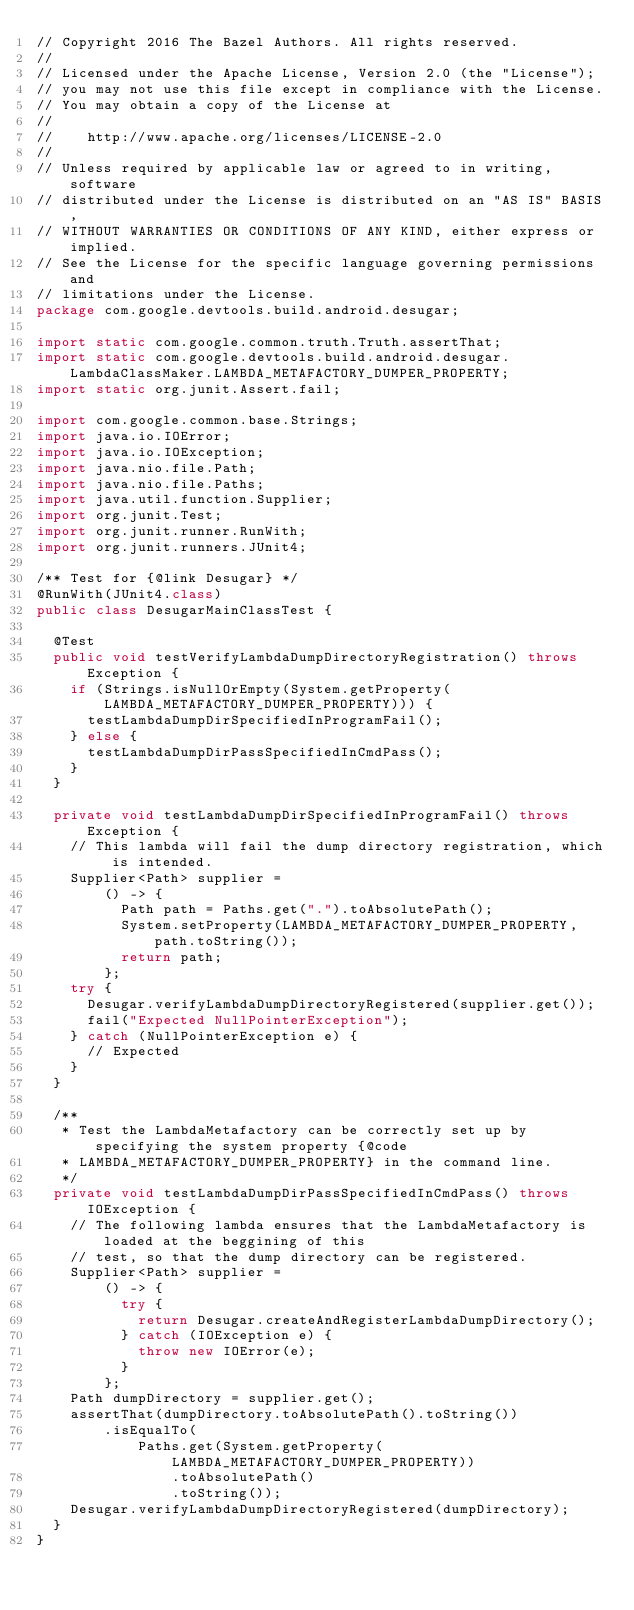Convert code to text. <code><loc_0><loc_0><loc_500><loc_500><_Java_>// Copyright 2016 The Bazel Authors. All rights reserved.
//
// Licensed under the Apache License, Version 2.0 (the "License");
// you may not use this file except in compliance with the License.
// You may obtain a copy of the License at
//
//    http://www.apache.org/licenses/LICENSE-2.0
//
// Unless required by applicable law or agreed to in writing, software
// distributed under the License is distributed on an "AS IS" BASIS,
// WITHOUT WARRANTIES OR CONDITIONS OF ANY KIND, either express or implied.
// See the License for the specific language governing permissions and
// limitations under the License.
package com.google.devtools.build.android.desugar;

import static com.google.common.truth.Truth.assertThat;
import static com.google.devtools.build.android.desugar.LambdaClassMaker.LAMBDA_METAFACTORY_DUMPER_PROPERTY;
import static org.junit.Assert.fail;

import com.google.common.base.Strings;
import java.io.IOError;
import java.io.IOException;
import java.nio.file.Path;
import java.nio.file.Paths;
import java.util.function.Supplier;
import org.junit.Test;
import org.junit.runner.RunWith;
import org.junit.runners.JUnit4;

/** Test for {@link Desugar} */
@RunWith(JUnit4.class)
public class DesugarMainClassTest {

  @Test
  public void testVerifyLambdaDumpDirectoryRegistration() throws Exception {
    if (Strings.isNullOrEmpty(System.getProperty(LAMBDA_METAFACTORY_DUMPER_PROPERTY))) {
      testLambdaDumpDirSpecifiedInProgramFail();
    } else {
      testLambdaDumpDirPassSpecifiedInCmdPass();
    }
  }

  private void testLambdaDumpDirSpecifiedInProgramFail() throws Exception {
    // This lambda will fail the dump directory registration, which is intended.
    Supplier<Path> supplier =
        () -> {
          Path path = Paths.get(".").toAbsolutePath();
          System.setProperty(LAMBDA_METAFACTORY_DUMPER_PROPERTY, path.toString());
          return path;
        };
    try {
      Desugar.verifyLambdaDumpDirectoryRegistered(supplier.get());
      fail("Expected NullPointerException");
    } catch (NullPointerException e) {
      // Expected
    }
  }

  /**
   * Test the LambdaMetafactory can be correctly set up by specifying the system property {@code
   * LAMBDA_METAFACTORY_DUMPER_PROPERTY} in the command line.
   */
  private void testLambdaDumpDirPassSpecifiedInCmdPass() throws IOException {
    // The following lambda ensures that the LambdaMetafactory is loaded at the beggining of this
    // test, so that the dump directory can be registered.
    Supplier<Path> supplier =
        () -> {
          try {
            return Desugar.createAndRegisterLambdaDumpDirectory();
          } catch (IOException e) {
            throw new IOError(e);
          }
        };
    Path dumpDirectory = supplier.get();
    assertThat(dumpDirectory.toAbsolutePath().toString())
        .isEqualTo(
            Paths.get(System.getProperty(LAMBDA_METAFACTORY_DUMPER_PROPERTY))
                .toAbsolutePath()
                .toString());
    Desugar.verifyLambdaDumpDirectoryRegistered(dumpDirectory);
  }
}
</code> 